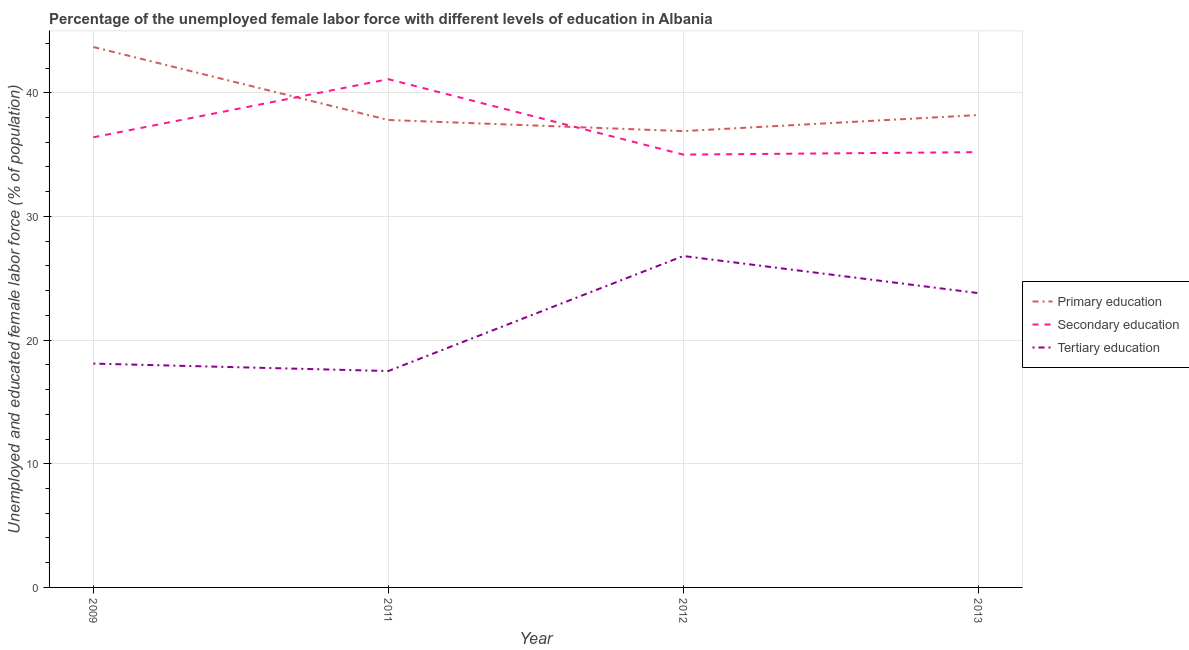How many different coloured lines are there?
Keep it short and to the point. 3. What is the percentage of female labor force who received primary education in 2009?
Provide a succinct answer. 43.7. Across all years, what is the maximum percentage of female labor force who received secondary education?
Make the answer very short. 41.1. Across all years, what is the minimum percentage of female labor force who received tertiary education?
Offer a very short reply. 17.5. What is the total percentage of female labor force who received tertiary education in the graph?
Give a very brief answer. 86.2. What is the difference between the percentage of female labor force who received tertiary education in 2009 and that in 2011?
Ensure brevity in your answer.  0.6. What is the difference between the percentage of female labor force who received primary education in 2013 and the percentage of female labor force who received secondary education in 2009?
Your answer should be very brief. 1.8. What is the average percentage of female labor force who received primary education per year?
Your response must be concise. 39.15. In the year 2013, what is the difference between the percentage of female labor force who received tertiary education and percentage of female labor force who received primary education?
Offer a very short reply. -14.4. In how many years, is the percentage of female labor force who received primary education greater than 14 %?
Keep it short and to the point. 4. What is the ratio of the percentage of female labor force who received primary education in 2011 to that in 2013?
Ensure brevity in your answer.  0.99. What is the difference between the highest and the second highest percentage of female labor force who received secondary education?
Your answer should be compact. 4.7. What is the difference between the highest and the lowest percentage of female labor force who received secondary education?
Your answer should be very brief. 6.1. In how many years, is the percentage of female labor force who received primary education greater than the average percentage of female labor force who received primary education taken over all years?
Make the answer very short. 1. Is it the case that in every year, the sum of the percentage of female labor force who received primary education and percentage of female labor force who received secondary education is greater than the percentage of female labor force who received tertiary education?
Offer a very short reply. Yes. Does the percentage of female labor force who received tertiary education monotonically increase over the years?
Offer a very short reply. No. Is the percentage of female labor force who received tertiary education strictly greater than the percentage of female labor force who received secondary education over the years?
Offer a terse response. No. Are the values on the major ticks of Y-axis written in scientific E-notation?
Offer a terse response. No. Does the graph contain any zero values?
Make the answer very short. No. Where does the legend appear in the graph?
Give a very brief answer. Center right. How many legend labels are there?
Give a very brief answer. 3. How are the legend labels stacked?
Offer a very short reply. Vertical. What is the title of the graph?
Offer a very short reply. Percentage of the unemployed female labor force with different levels of education in Albania. Does "Slovak Republic" appear as one of the legend labels in the graph?
Give a very brief answer. No. What is the label or title of the Y-axis?
Your answer should be very brief. Unemployed and educated female labor force (% of population). What is the Unemployed and educated female labor force (% of population) of Primary education in 2009?
Offer a very short reply. 43.7. What is the Unemployed and educated female labor force (% of population) of Secondary education in 2009?
Provide a succinct answer. 36.4. What is the Unemployed and educated female labor force (% of population) of Tertiary education in 2009?
Give a very brief answer. 18.1. What is the Unemployed and educated female labor force (% of population) in Primary education in 2011?
Provide a succinct answer. 37.8. What is the Unemployed and educated female labor force (% of population) of Secondary education in 2011?
Your answer should be very brief. 41.1. What is the Unemployed and educated female labor force (% of population) in Tertiary education in 2011?
Keep it short and to the point. 17.5. What is the Unemployed and educated female labor force (% of population) in Primary education in 2012?
Provide a succinct answer. 36.9. What is the Unemployed and educated female labor force (% of population) in Secondary education in 2012?
Your answer should be very brief. 35. What is the Unemployed and educated female labor force (% of population) in Tertiary education in 2012?
Your response must be concise. 26.8. What is the Unemployed and educated female labor force (% of population) in Primary education in 2013?
Make the answer very short. 38.2. What is the Unemployed and educated female labor force (% of population) in Secondary education in 2013?
Give a very brief answer. 35.2. What is the Unemployed and educated female labor force (% of population) of Tertiary education in 2013?
Keep it short and to the point. 23.8. Across all years, what is the maximum Unemployed and educated female labor force (% of population) in Primary education?
Make the answer very short. 43.7. Across all years, what is the maximum Unemployed and educated female labor force (% of population) of Secondary education?
Your response must be concise. 41.1. Across all years, what is the maximum Unemployed and educated female labor force (% of population) in Tertiary education?
Make the answer very short. 26.8. Across all years, what is the minimum Unemployed and educated female labor force (% of population) of Primary education?
Your answer should be very brief. 36.9. Across all years, what is the minimum Unemployed and educated female labor force (% of population) in Tertiary education?
Ensure brevity in your answer.  17.5. What is the total Unemployed and educated female labor force (% of population) in Primary education in the graph?
Provide a short and direct response. 156.6. What is the total Unemployed and educated female labor force (% of population) of Secondary education in the graph?
Provide a succinct answer. 147.7. What is the total Unemployed and educated female labor force (% of population) of Tertiary education in the graph?
Offer a very short reply. 86.2. What is the difference between the Unemployed and educated female labor force (% of population) of Secondary education in 2009 and that in 2011?
Provide a succinct answer. -4.7. What is the difference between the Unemployed and educated female labor force (% of population) of Secondary education in 2009 and that in 2012?
Give a very brief answer. 1.4. What is the difference between the Unemployed and educated female labor force (% of population) of Tertiary education in 2009 and that in 2012?
Provide a short and direct response. -8.7. What is the difference between the Unemployed and educated female labor force (% of population) of Secondary education in 2011 and that in 2012?
Give a very brief answer. 6.1. What is the difference between the Unemployed and educated female labor force (% of population) in Tertiary education in 2011 and that in 2012?
Make the answer very short. -9.3. What is the difference between the Unemployed and educated female labor force (% of population) in Primary education in 2011 and that in 2013?
Your answer should be compact. -0.4. What is the difference between the Unemployed and educated female labor force (% of population) in Primary education in 2012 and that in 2013?
Your response must be concise. -1.3. What is the difference between the Unemployed and educated female labor force (% of population) in Primary education in 2009 and the Unemployed and educated female labor force (% of population) in Tertiary education in 2011?
Offer a terse response. 26.2. What is the difference between the Unemployed and educated female labor force (% of population) of Secondary education in 2009 and the Unemployed and educated female labor force (% of population) of Tertiary education in 2011?
Make the answer very short. 18.9. What is the difference between the Unemployed and educated female labor force (% of population) of Primary education in 2009 and the Unemployed and educated female labor force (% of population) of Secondary education in 2012?
Make the answer very short. 8.7. What is the difference between the Unemployed and educated female labor force (% of population) in Primary education in 2009 and the Unemployed and educated female labor force (% of population) in Secondary education in 2013?
Offer a terse response. 8.5. What is the difference between the Unemployed and educated female labor force (% of population) in Secondary education in 2009 and the Unemployed and educated female labor force (% of population) in Tertiary education in 2013?
Your answer should be very brief. 12.6. What is the difference between the Unemployed and educated female labor force (% of population) of Primary education in 2011 and the Unemployed and educated female labor force (% of population) of Secondary education in 2012?
Provide a short and direct response. 2.8. What is the difference between the Unemployed and educated female labor force (% of population) of Secondary education in 2011 and the Unemployed and educated female labor force (% of population) of Tertiary education in 2012?
Provide a succinct answer. 14.3. What is the difference between the Unemployed and educated female labor force (% of population) in Primary education in 2011 and the Unemployed and educated female labor force (% of population) in Tertiary education in 2013?
Your answer should be very brief. 14. What is the difference between the Unemployed and educated female labor force (% of population) in Secondary education in 2011 and the Unemployed and educated female labor force (% of population) in Tertiary education in 2013?
Provide a short and direct response. 17.3. What is the difference between the Unemployed and educated female labor force (% of population) in Primary education in 2012 and the Unemployed and educated female labor force (% of population) in Secondary education in 2013?
Keep it short and to the point. 1.7. What is the difference between the Unemployed and educated female labor force (% of population) in Primary education in 2012 and the Unemployed and educated female labor force (% of population) in Tertiary education in 2013?
Your answer should be very brief. 13.1. What is the difference between the Unemployed and educated female labor force (% of population) of Secondary education in 2012 and the Unemployed and educated female labor force (% of population) of Tertiary education in 2013?
Give a very brief answer. 11.2. What is the average Unemployed and educated female labor force (% of population) in Primary education per year?
Give a very brief answer. 39.15. What is the average Unemployed and educated female labor force (% of population) in Secondary education per year?
Give a very brief answer. 36.92. What is the average Unemployed and educated female labor force (% of population) of Tertiary education per year?
Your answer should be compact. 21.55. In the year 2009, what is the difference between the Unemployed and educated female labor force (% of population) in Primary education and Unemployed and educated female labor force (% of population) in Tertiary education?
Your answer should be compact. 25.6. In the year 2009, what is the difference between the Unemployed and educated female labor force (% of population) of Secondary education and Unemployed and educated female labor force (% of population) of Tertiary education?
Your response must be concise. 18.3. In the year 2011, what is the difference between the Unemployed and educated female labor force (% of population) of Primary education and Unemployed and educated female labor force (% of population) of Secondary education?
Give a very brief answer. -3.3. In the year 2011, what is the difference between the Unemployed and educated female labor force (% of population) in Primary education and Unemployed and educated female labor force (% of population) in Tertiary education?
Your answer should be compact. 20.3. In the year 2011, what is the difference between the Unemployed and educated female labor force (% of population) of Secondary education and Unemployed and educated female labor force (% of population) of Tertiary education?
Offer a very short reply. 23.6. In the year 2012, what is the difference between the Unemployed and educated female labor force (% of population) in Secondary education and Unemployed and educated female labor force (% of population) in Tertiary education?
Your response must be concise. 8.2. In the year 2013, what is the difference between the Unemployed and educated female labor force (% of population) in Primary education and Unemployed and educated female labor force (% of population) in Secondary education?
Offer a terse response. 3. In the year 2013, what is the difference between the Unemployed and educated female labor force (% of population) of Primary education and Unemployed and educated female labor force (% of population) of Tertiary education?
Your answer should be compact. 14.4. What is the ratio of the Unemployed and educated female labor force (% of population) in Primary education in 2009 to that in 2011?
Your answer should be very brief. 1.16. What is the ratio of the Unemployed and educated female labor force (% of population) of Secondary education in 2009 to that in 2011?
Provide a short and direct response. 0.89. What is the ratio of the Unemployed and educated female labor force (% of population) of Tertiary education in 2009 to that in 2011?
Ensure brevity in your answer.  1.03. What is the ratio of the Unemployed and educated female labor force (% of population) of Primary education in 2009 to that in 2012?
Make the answer very short. 1.18. What is the ratio of the Unemployed and educated female labor force (% of population) in Tertiary education in 2009 to that in 2012?
Make the answer very short. 0.68. What is the ratio of the Unemployed and educated female labor force (% of population) in Primary education in 2009 to that in 2013?
Keep it short and to the point. 1.14. What is the ratio of the Unemployed and educated female labor force (% of population) in Secondary education in 2009 to that in 2013?
Ensure brevity in your answer.  1.03. What is the ratio of the Unemployed and educated female labor force (% of population) in Tertiary education in 2009 to that in 2013?
Provide a short and direct response. 0.76. What is the ratio of the Unemployed and educated female labor force (% of population) of Primary education in 2011 to that in 2012?
Offer a very short reply. 1.02. What is the ratio of the Unemployed and educated female labor force (% of population) in Secondary education in 2011 to that in 2012?
Your answer should be very brief. 1.17. What is the ratio of the Unemployed and educated female labor force (% of population) in Tertiary education in 2011 to that in 2012?
Offer a very short reply. 0.65. What is the ratio of the Unemployed and educated female labor force (% of population) of Primary education in 2011 to that in 2013?
Ensure brevity in your answer.  0.99. What is the ratio of the Unemployed and educated female labor force (% of population) in Secondary education in 2011 to that in 2013?
Your answer should be compact. 1.17. What is the ratio of the Unemployed and educated female labor force (% of population) in Tertiary education in 2011 to that in 2013?
Ensure brevity in your answer.  0.74. What is the ratio of the Unemployed and educated female labor force (% of population) of Primary education in 2012 to that in 2013?
Your answer should be compact. 0.97. What is the ratio of the Unemployed and educated female labor force (% of population) in Tertiary education in 2012 to that in 2013?
Provide a short and direct response. 1.13. What is the difference between the highest and the second highest Unemployed and educated female labor force (% of population) of Secondary education?
Your answer should be very brief. 4.7. 